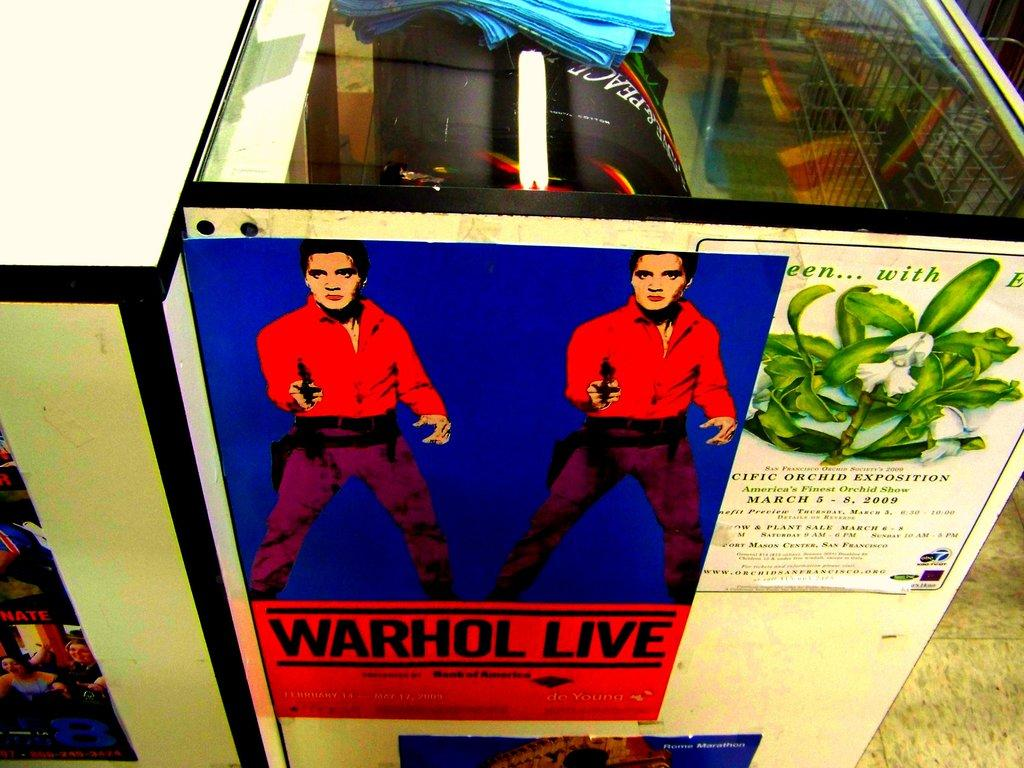How many tables are present in the image? There are two tables in the image. What can be seen on the tables? There are posters on the tables. What is inside the tables? There are objects inside the tables. What part of the room can be seen at the bottom of the image? The floor is visible at the bottom of the image. What type of music can be heard coming from the top of the tables in the image? There is no music present in the image, and the top of the tables cannot be seen. 